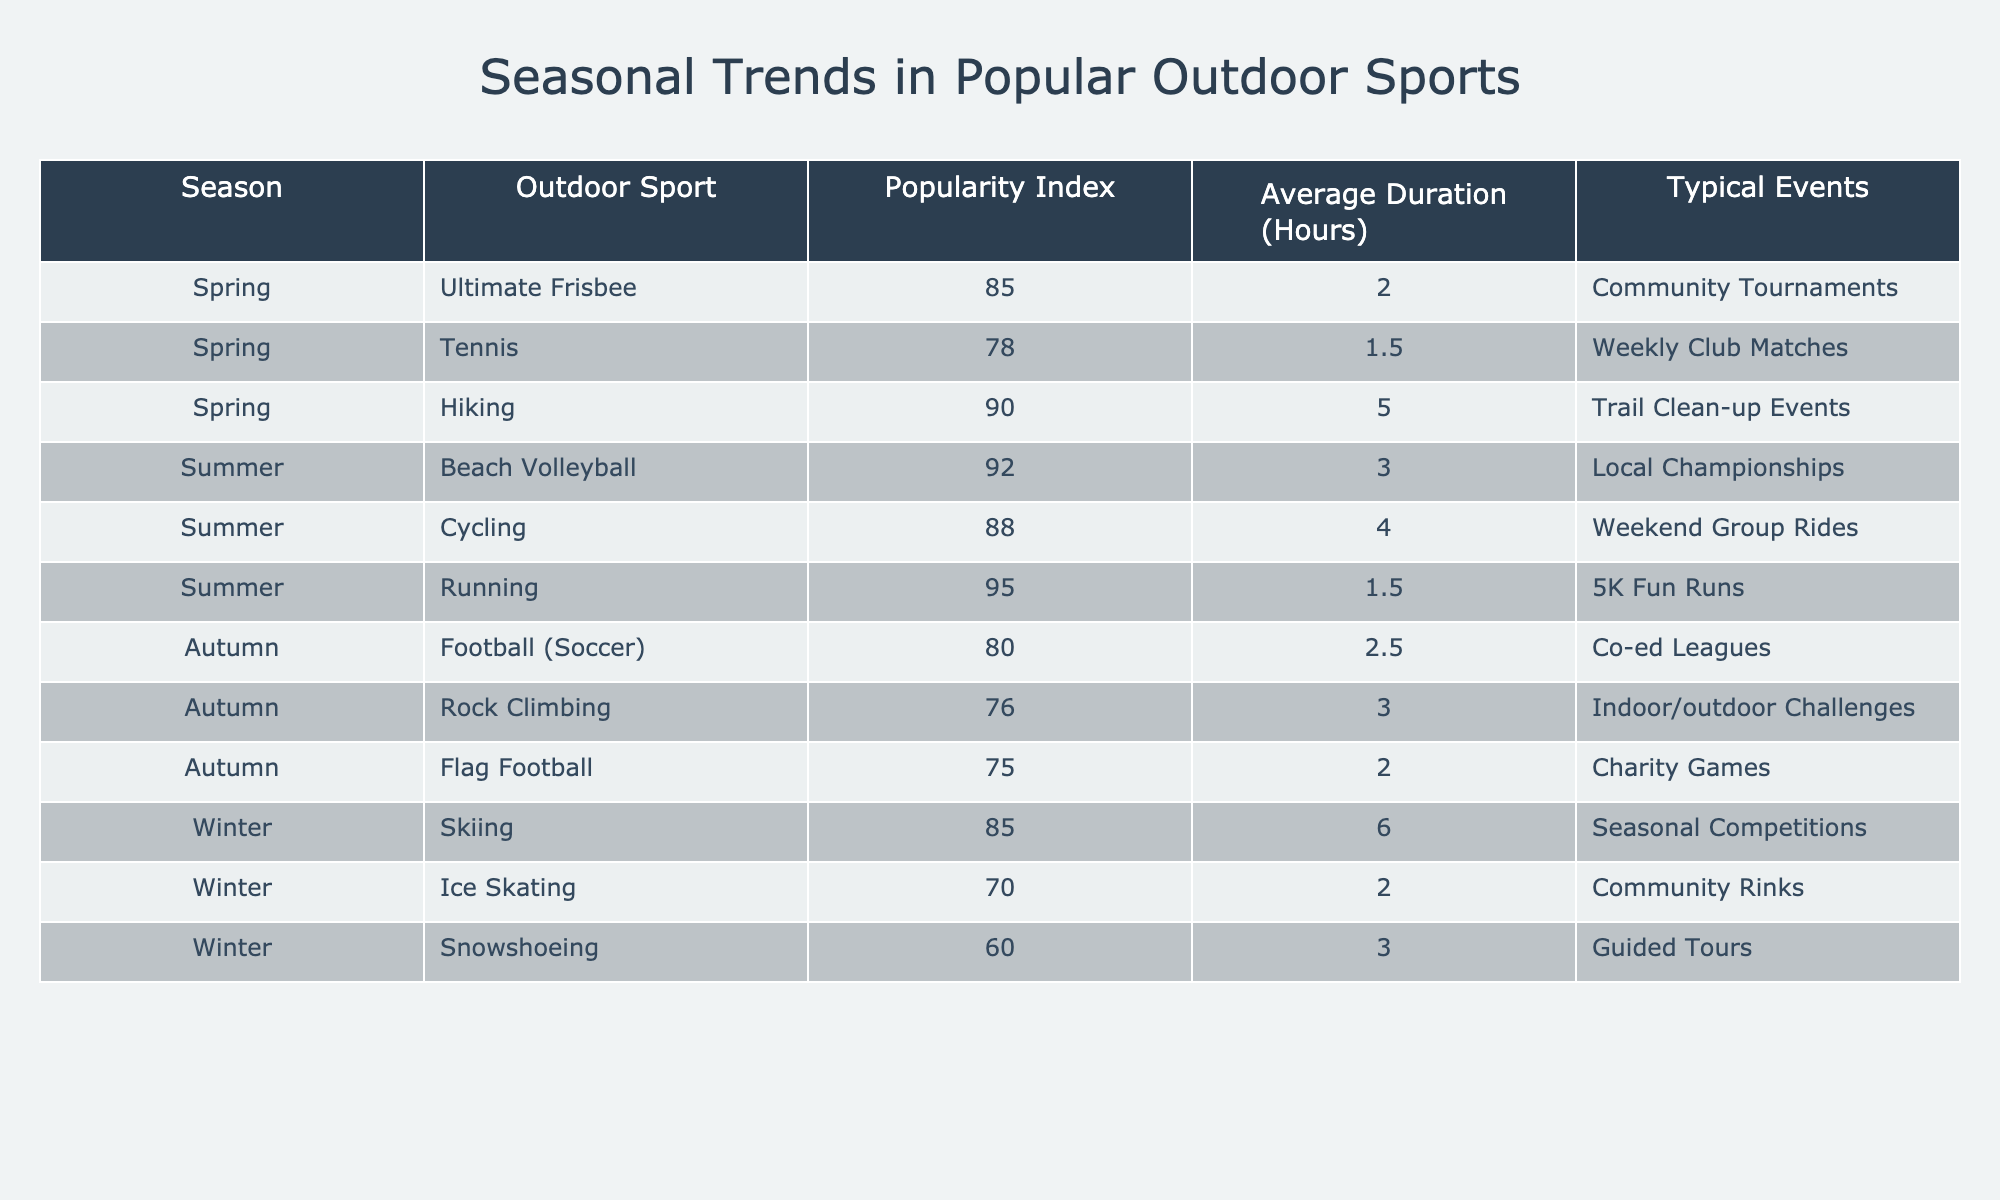What is the popularity index for Hiking in Spring? The table shows that the popularity index for Hiking in Spring is 90.
Answer: 90 Which outdoor sport has the highest popularity index in Summer? According to the table, Running has the highest popularity index in Summer at 95.
Answer: 95 How many hours on average does a game of Beach Volleyball last? The average duration for Beach Volleyball is listed as 3 hours in the table.
Answer: 3 Is the popularity index of Flag Football higher than that of Rock Climbing in Autumn? The table shows Flag Football has a popularity index of 75, while Rock Climbing has an index of 76, indicating Flag Football is lower.
Answer: No What is the difference in average duration between Skiing and Snowshoeing? The average duration for Skiing is 6 hours, and for Snowshoeing, it is 3 hours. The difference is 6 - 3 = 3 hours.
Answer: 3 hours Which season has the highest overall average duration for its sports activities? The average duration for each season is calculated: Spring = (2 + 1.5 + 5)/3 = 2.83, Summer = (3 + 4 + 1.5)/3 = 2.83, Autumn = (2.5 + 3 + 2)/3 = 2.5, Winter = (6 + 2 + 3)/3 = 3.67. Winter has the highest average duration.
Answer: Winter What is the average popularity index for outdoor sports during Autumn? The popularity indices for Autumn are 80 (Football), 76 (Rock Climbing), and 75 (Flag Football). The average is (80 + 76 + 75)/3 = 77.
Answer: 77 Does Ice Skating have a higher popularity index than Ultimate Frisbee in the table? Ice Skating has a popularity index of 70 while Ultimate Frisbee has 85, showing Ice Skating is lower.
Answer: No Which outdoor sport has the least average duration in Spring? The table indicates that Tennis has the least average duration in Spring at 1.5 hours.
Answer: Tennis If we combined the popularity indices of Cycling and Running, what would the total be? The popularity index for Cycling is 88 and for Running, it’s 95. Combining these gives 88 + 95 = 183.
Answer: 183 